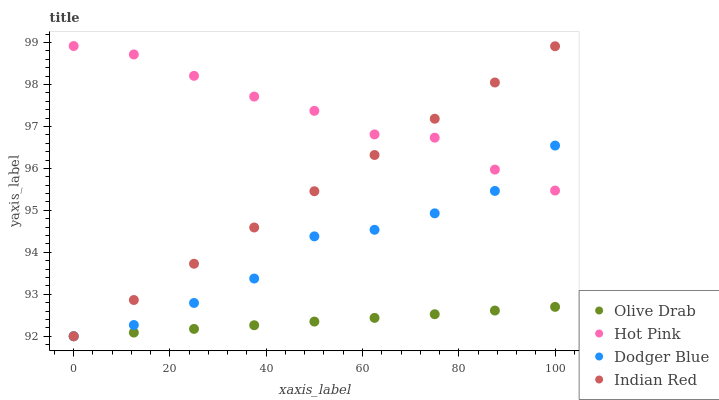Does Olive Drab have the minimum area under the curve?
Answer yes or no. Yes. Does Hot Pink have the maximum area under the curve?
Answer yes or no. Yes. Does Dodger Blue have the minimum area under the curve?
Answer yes or no. No. Does Dodger Blue have the maximum area under the curve?
Answer yes or no. No. Is Olive Drab the smoothest?
Answer yes or no. Yes. Is Dodger Blue the roughest?
Answer yes or no. Yes. Is Indian Red the smoothest?
Answer yes or no. No. Is Indian Red the roughest?
Answer yes or no. No. Does Dodger Blue have the lowest value?
Answer yes or no. Yes. Does Hot Pink have the highest value?
Answer yes or no. Yes. Does Dodger Blue have the highest value?
Answer yes or no. No. Is Olive Drab less than Hot Pink?
Answer yes or no. Yes. Is Hot Pink greater than Olive Drab?
Answer yes or no. Yes. Does Indian Red intersect Olive Drab?
Answer yes or no. Yes. Is Indian Red less than Olive Drab?
Answer yes or no. No. Is Indian Red greater than Olive Drab?
Answer yes or no. No. Does Olive Drab intersect Hot Pink?
Answer yes or no. No. 